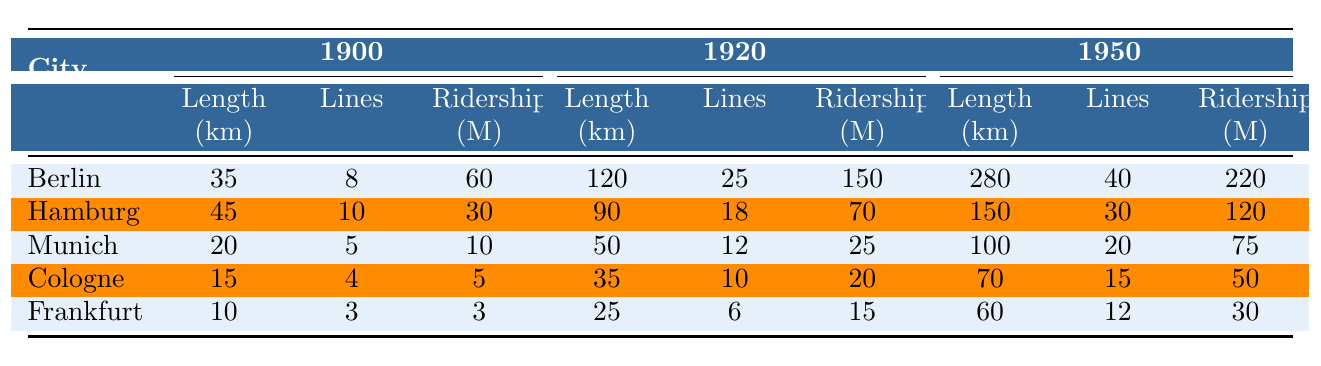What was the total tram network length in Berlin by 1950? In the table, the length of the tram network in Berlin in 1950 is clearly noted as 280 km.
Answer: 280 km How many tram lines were operating in Hamburg in 1920? According to the table, the number of tram lines in Hamburg in 1920 is 18 lines.
Answer: 18 Did Munich have more passenger ridership in 1920 than Cologne? In the table, Munich's ridership in 1920 is 25 million, while Cologne's is 20 million. Since 25 is greater than 20, the statement is true.
Answer: Yes What was the increase in length of tram networks in Frankfurt from 1900 to 1950? The length of the tram network in Frankfurt in 1900 was 10 km, and in 1950 it was 60 km. The increase can be calculated as 60 km - 10 km = 50 km.
Answer: 50 km What was the average passenger ridership for the cities listed in 1950? To find the average ridership in 1950, sum the ridership figures for all cities: (220 + 120 + 75 + 50 + 30) = 495 million. There are 5 cities, so the average is 495/5 = 99 million.
Answer: 99 million Which city had the least tram network length in 1900? By examining the table, Cologne had the least length at 15 km in 1900, compared to Berlin, Hamburg, Munich, and Frankfurt.
Answer: Cologne How much did the number of tram lines increase in Berlin from 1900 to 1950? Berlin had 8 lines in 1900 and 40 lines in 1950. The increase is 40 lines - 8 lines = 32 lines.
Answer: 32 lines Is the total passenger ridership in Hamburg higher in 1950 than in 1920? The table shows Hamburg's ridership was 70 million in 1920 and 120 million in 1950. Since 120 million is greater than 70 million, the statement is true.
Answer: Yes What percentage increase in tram length did Munich experience from 1900 to 1950? Munich had a tram length of 20 km in 1900 and 100 km in 1950. The increase is 100 km - 20 km = 80 km. To find the percentage increase, calculate (80/20) * 100 = 400%.
Answer: 400% 